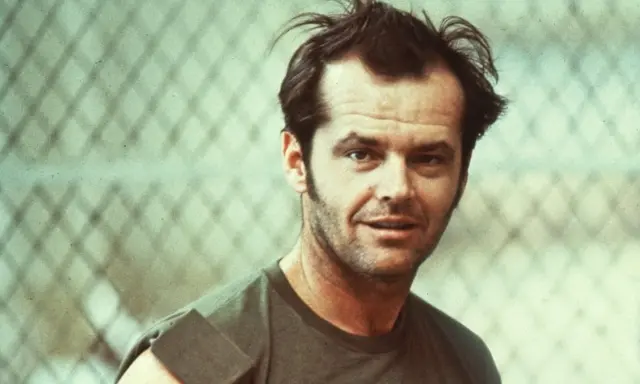Can you tell me more about the time period this image seems to represent? This image appears to be from the late 1960s or early 1970s, as suggested by the faded color palette and the style of clothing. During this period, casual attire like tank tops and disheveled hair were commonplace, reflecting a more relaxed and rebellious cultural vibe of the time. The use of film photography, evident from the image’s vintage look, was prevalent before the digital age. 